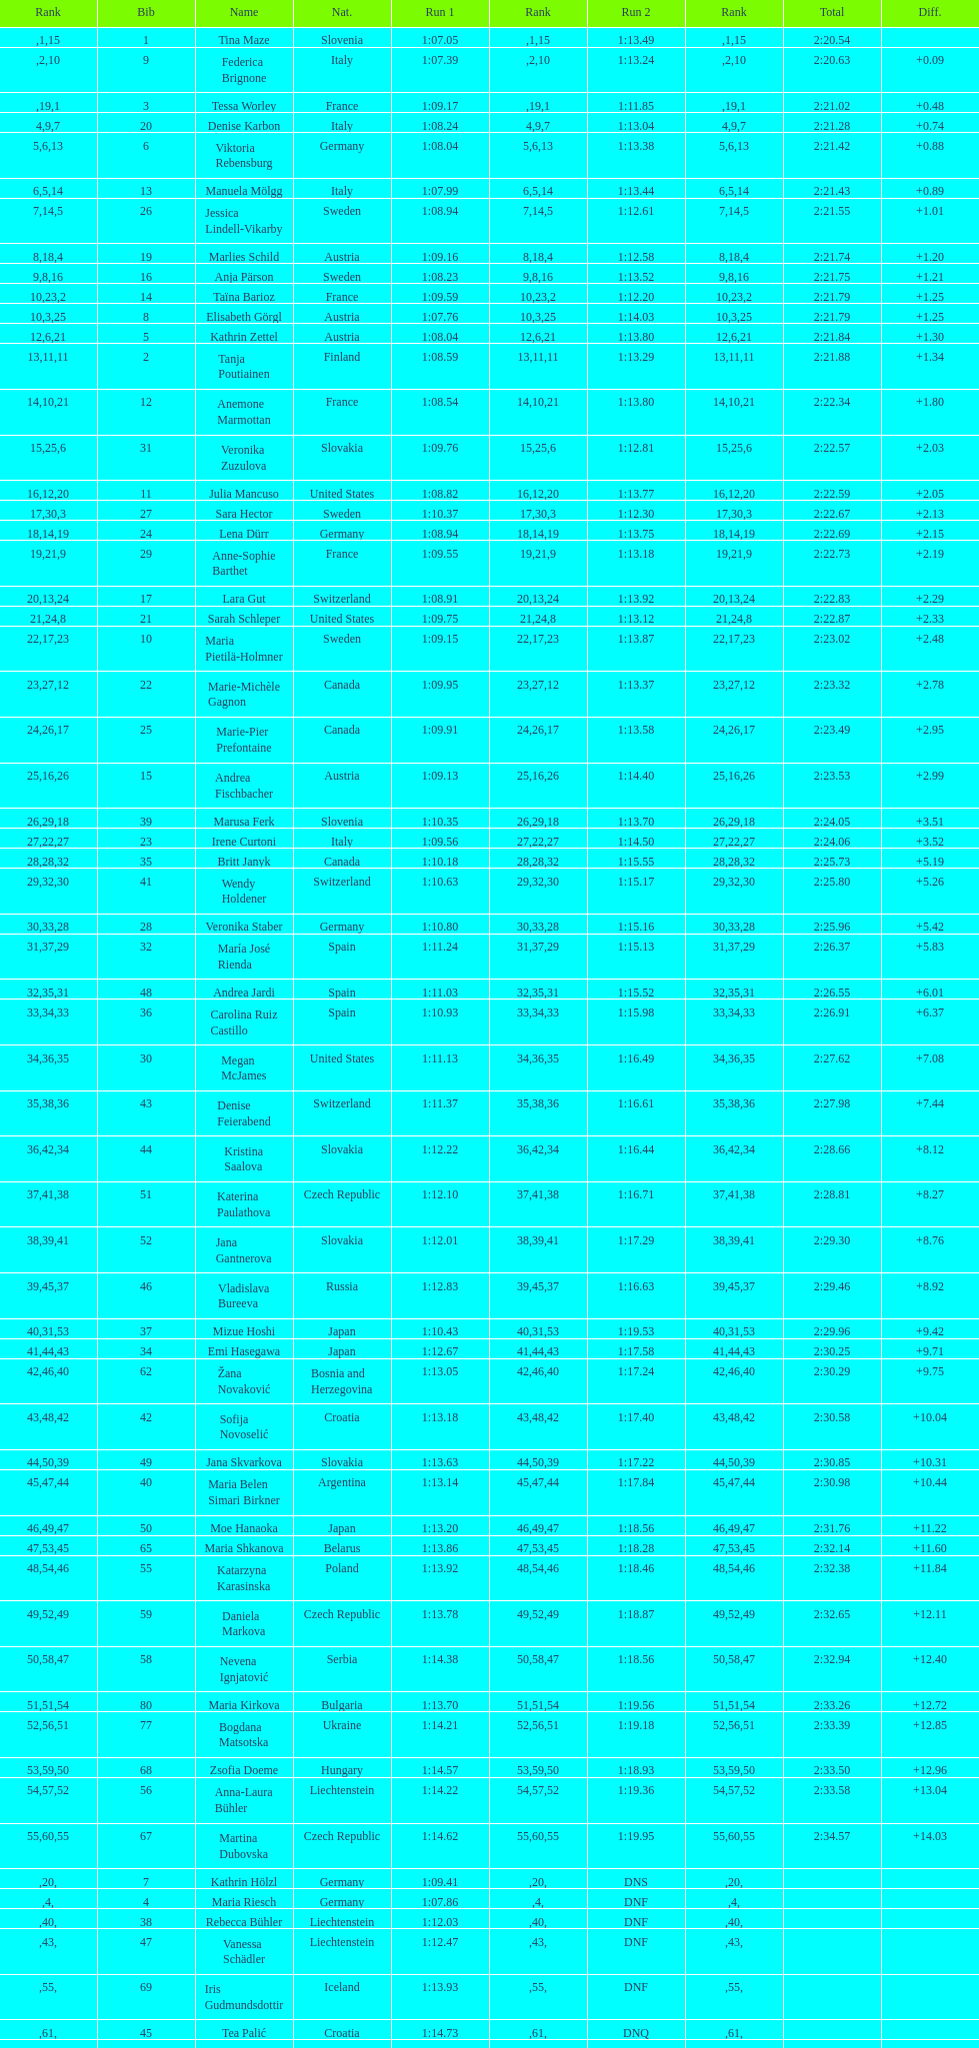How many total names are there? 116. 